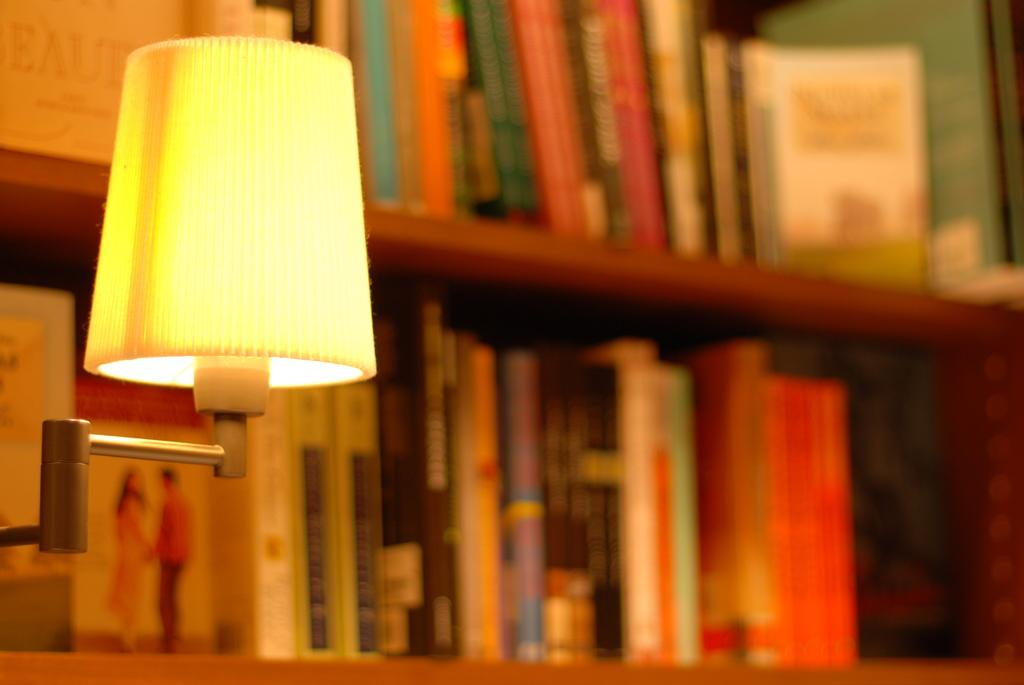What object can be seen in the image that provides light? There is a lamp in the image. What can be seen in the background of the image? There are books in the shelves in the background of the image. What type of net is being used to catch the books in the image? There is no net present in the image, and the books are not being caught. 